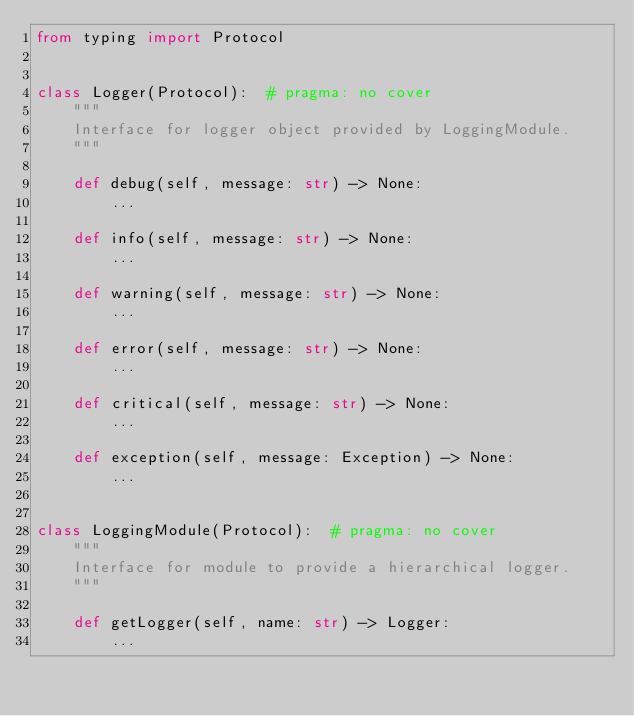Convert code to text. <code><loc_0><loc_0><loc_500><loc_500><_Python_>from typing import Protocol


class Logger(Protocol):  # pragma: no cover
    """
    Interface for logger object provided by LoggingModule.
    """

    def debug(self, message: str) -> None:
        ...

    def info(self, message: str) -> None:
        ...

    def warning(self, message: str) -> None:
        ...

    def error(self, message: str) -> None:
        ...

    def critical(self, message: str) -> None:
        ...

    def exception(self, message: Exception) -> None:
        ...


class LoggingModule(Protocol):  # pragma: no cover
    """
    Interface for module to provide a hierarchical logger.
    """

    def getLogger(self, name: str) -> Logger:
        ...
</code> 